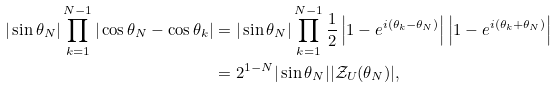<formula> <loc_0><loc_0><loc_500><loc_500>| \sin \theta _ { N } | \prod _ { k = 1 } ^ { N - 1 } | \cos \theta _ { N } - \cos \theta _ { k } | & = | \sin \theta _ { N } | \prod _ { k = 1 } ^ { N - 1 } \frac { 1 } { 2 } \left | 1 - e ^ { i ( \theta _ { k } - \theta _ { N } ) } \right | \left | 1 - e ^ { i ( \theta _ { k } + \theta _ { N } ) } \right | \\ & = 2 ^ { 1 - N } | \sin \theta _ { N } | | \mathcal { Z } _ { U } ( \theta _ { N } ) | ,</formula> 